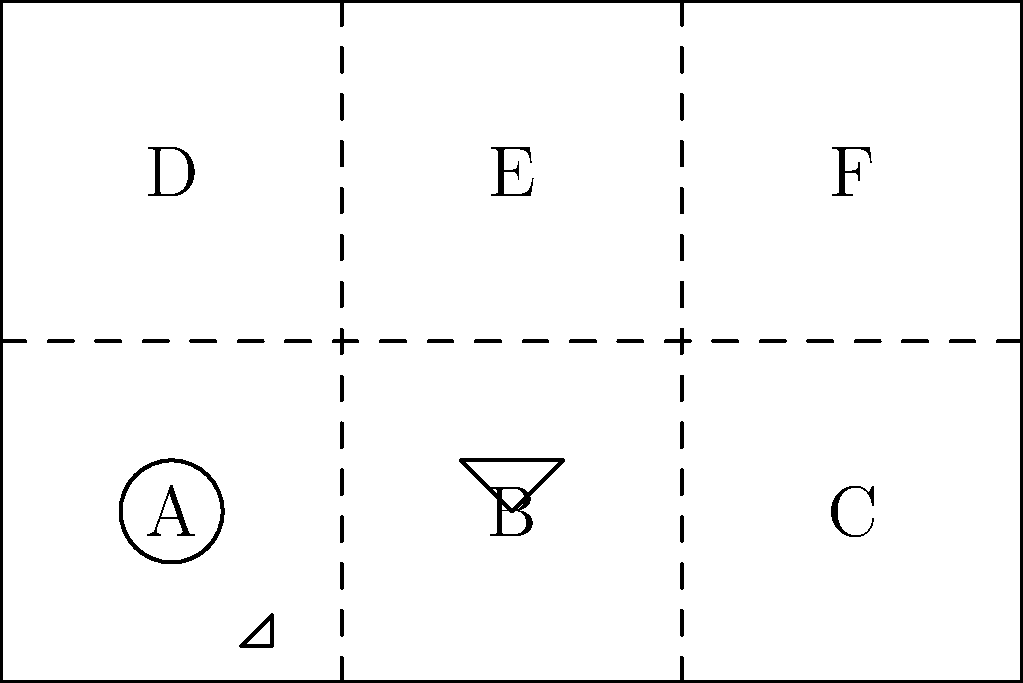A rectangular paper is divided into six sections (A-F) as shown, each containing a different cultural symbol. If the paper is folded along the dotted lines to create a cube, which symbol will be opposite the triangle? To solve this problem, we need to visualize how the paper will fold into a cube:

1. The paper will fold along the dotted lines, creating a cube with six faces.
2. Sections A, B, and C will form the bottom, front, and right faces of the cube respectively.
3. Sections D, E, and F will form the left, back, and top faces of the cube respectively.
4. The triangle is in section B, which becomes the front face of the cube.
5. The opposite face to the front is the back, which is section E.
6. Section E contains a filled triangle symbol.

Therefore, when the paper is folded into a cube, the symbol opposite the triangle will be the filled triangle.
Answer: Filled triangle 